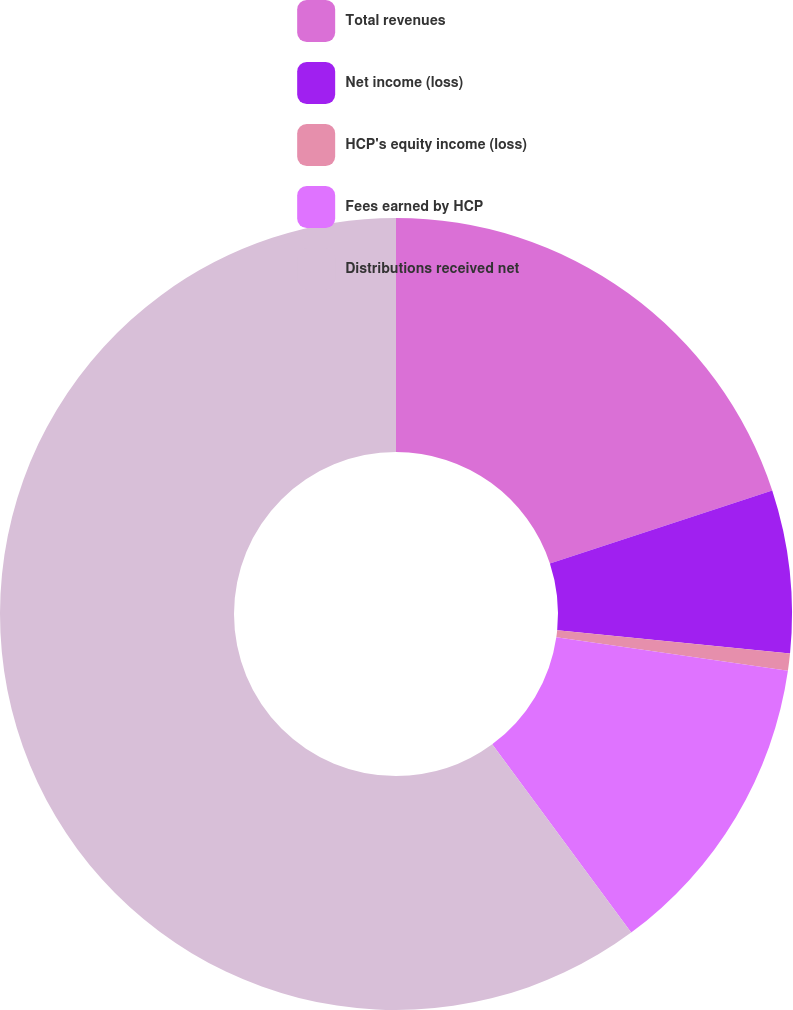Convert chart to OTSL. <chart><loc_0><loc_0><loc_500><loc_500><pie_chart><fcel>Total revenues<fcel>Net income (loss)<fcel>HCP's equity income (loss)<fcel>Fees earned by HCP<fcel>Distributions received net<nl><fcel>19.95%<fcel>6.64%<fcel>0.7%<fcel>12.59%<fcel>60.12%<nl></chart> 